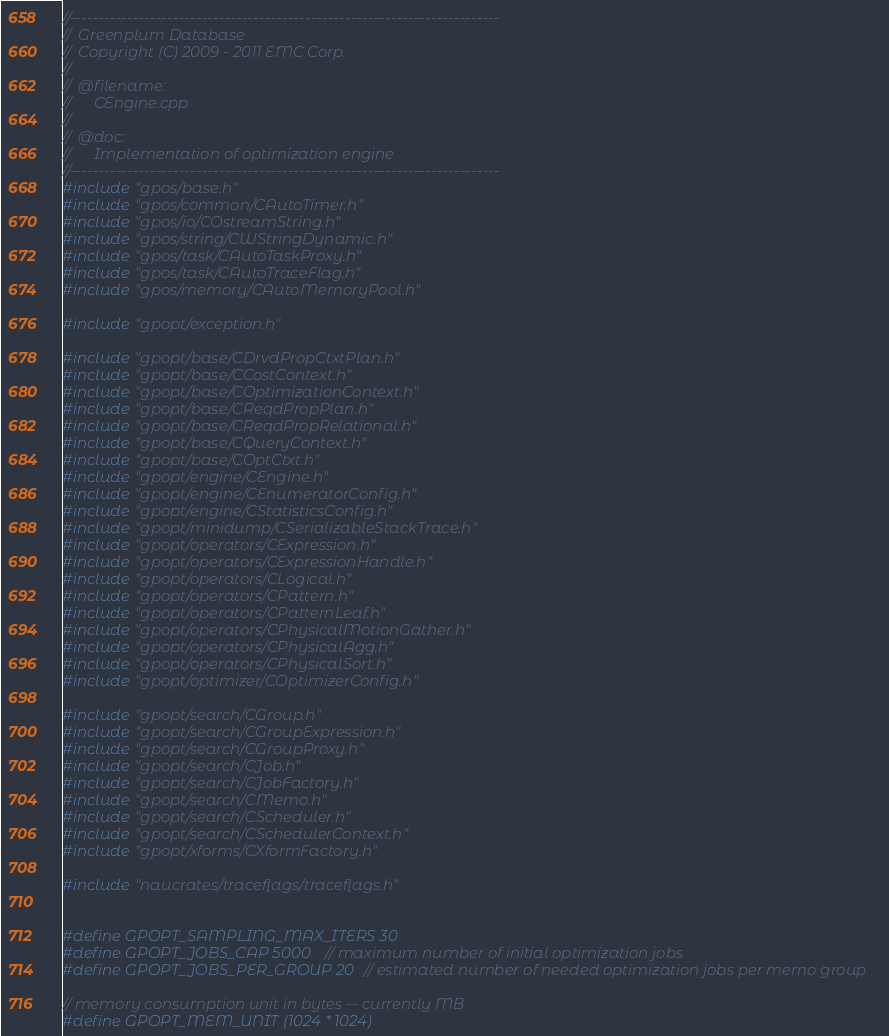Convert code to text. <code><loc_0><loc_0><loc_500><loc_500><_C++_>//---------------------------------------------------------------------------
//	Greenplum Database
//	Copyright (C) 2009 - 2011 EMC Corp.
//
//	@filename:
//		CEngine.cpp
//
//	@doc:
//		Implementation of optimization engine
//---------------------------------------------------------------------------
#include "gpos/base.h"
#include "gpos/common/CAutoTimer.h"
#include "gpos/io/COstreamString.h"
#include "gpos/string/CWStringDynamic.h"
#include "gpos/task/CAutoTaskProxy.h"
#include "gpos/task/CAutoTraceFlag.h"
#include "gpos/memory/CAutoMemoryPool.h"

#include "gpopt/exception.h"

#include "gpopt/base/CDrvdPropCtxtPlan.h"
#include "gpopt/base/CCostContext.h"
#include "gpopt/base/COptimizationContext.h"
#include "gpopt/base/CReqdPropPlan.h"
#include "gpopt/base/CReqdPropRelational.h"
#include "gpopt/base/CQueryContext.h"
#include "gpopt/base/COptCtxt.h"
#include "gpopt/engine/CEngine.h"
#include "gpopt/engine/CEnumeratorConfig.h"
#include "gpopt/engine/CStatisticsConfig.h"
#include "gpopt/minidump/CSerializableStackTrace.h"
#include "gpopt/operators/CExpression.h"
#include "gpopt/operators/CExpressionHandle.h"
#include "gpopt/operators/CLogical.h"
#include "gpopt/operators/CPattern.h"
#include "gpopt/operators/CPatternLeaf.h"
#include "gpopt/operators/CPhysicalMotionGather.h"
#include "gpopt/operators/CPhysicalAgg.h"
#include "gpopt/operators/CPhysicalSort.h"
#include "gpopt/optimizer/COptimizerConfig.h"

#include "gpopt/search/CGroup.h"
#include "gpopt/search/CGroupExpression.h"
#include "gpopt/search/CGroupProxy.h"
#include "gpopt/search/CJob.h"
#include "gpopt/search/CJobFactory.h"
#include "gpopt/search/CMemo.h"
#include "gpopt/search/CScheduler.h"
#include "gpopt/search/CSchedulerContext.h"
#include "gpopt/xforms/CXformFactory.h"

#include "naucrates/traceflags/traceflags.h"


#define GPOPT_SAMPLING_MAX_ITERS 30
#define GPOPT_JOBS_CAP 5000  // maximum number of initial optimization jobs
#define GPOPT_JOBS_PER_GROUP 20 // estimated number of needed optimization jobs per memo group

// memory consumption unit in bytes -- currently MB
#define GPOPT_MEM_UNIT (1024 * 1024)</code> 